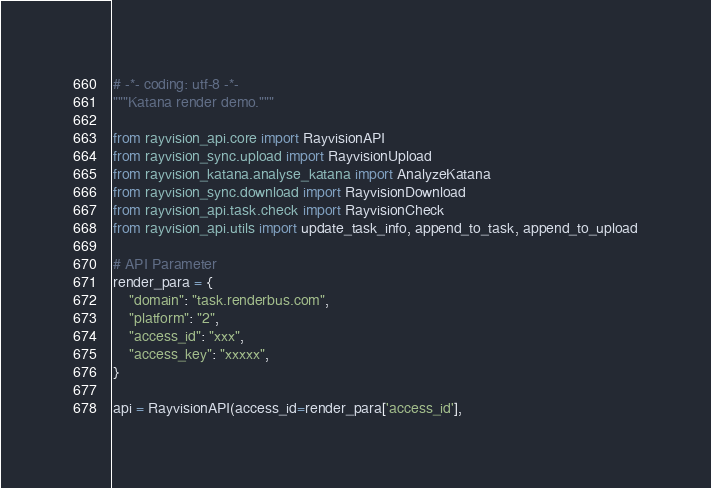Convert code to text. <code><loc_0><loc_0><loc_500><loc_500><_Python_># -*- coding: utf-8 -*-
"""Katana render demo."""

from rayvision_api.core import RayvisionAPI
from rayvision_sync.upload import RayvisionUpload
from rayvision_katana.analyse_katana import AnalyzeKatana
from rayvision_sync.download import RayvisionDownload
from rayvision_api.task.check import RayvisionCheck
from rayvision_api.utils import update_task_info, append_to_task, append_to_upload

# API Parameter
render_para = {
    "domain": "task.renderbus.com",
    "platform": "2",
    "access_id": "xxx",
    "access_key": "xxxxx",
}

api = RayvisionAPI(access_id=render_para['access_id'],</code> 